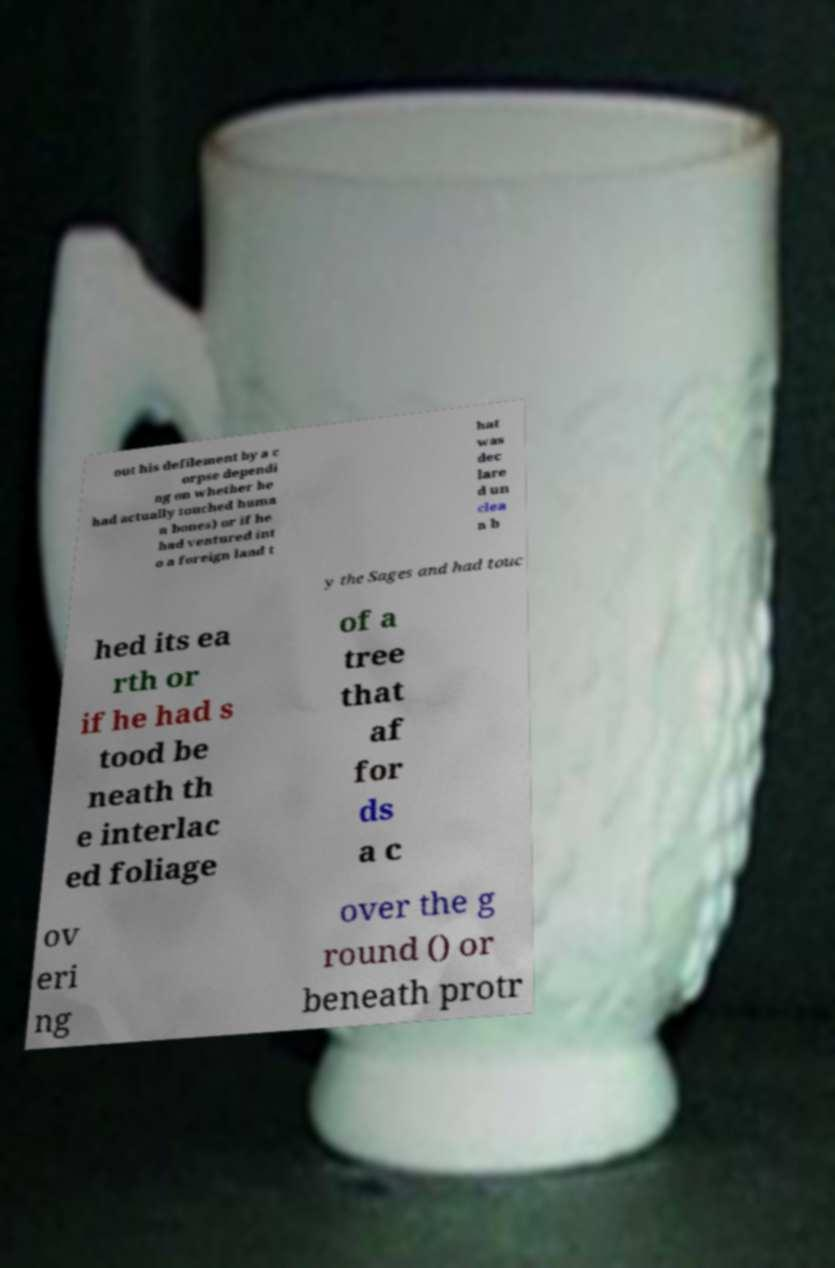Please identify and transcribe the text found in this image. out his defilement by a c orpse dependi ng on whether he had actually touched huma n bones) or if he had ventured int o a foreign land t hat was dec lare d un clea n b y the Sages and had touc hed its ea rth or if he had s tood be neath th e interlac ed foliage of a tree that af for ds a c ov eri ng over the g round () or beneath protr 